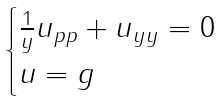<formula> <loc_0><loc_0><loc_500><loc_500>\begin{cases} \frac { 1 } { y } u _ { p p } + u _ { y y } = 0 & \\ u = g & \\ \end{cases}</formula> 